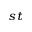<formula> <loc_0><loc_0><loc_500><loc_500>^ { s t }</formula> 